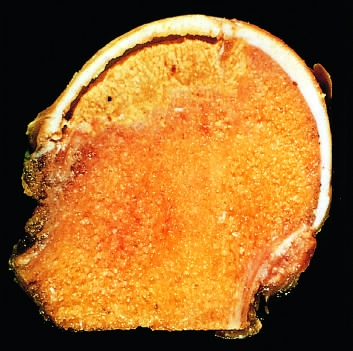what is the space between the overlying articular cartilage and bone caused by?
Answer the question using a single word or phrase. Trabecular compression fractures without repair 